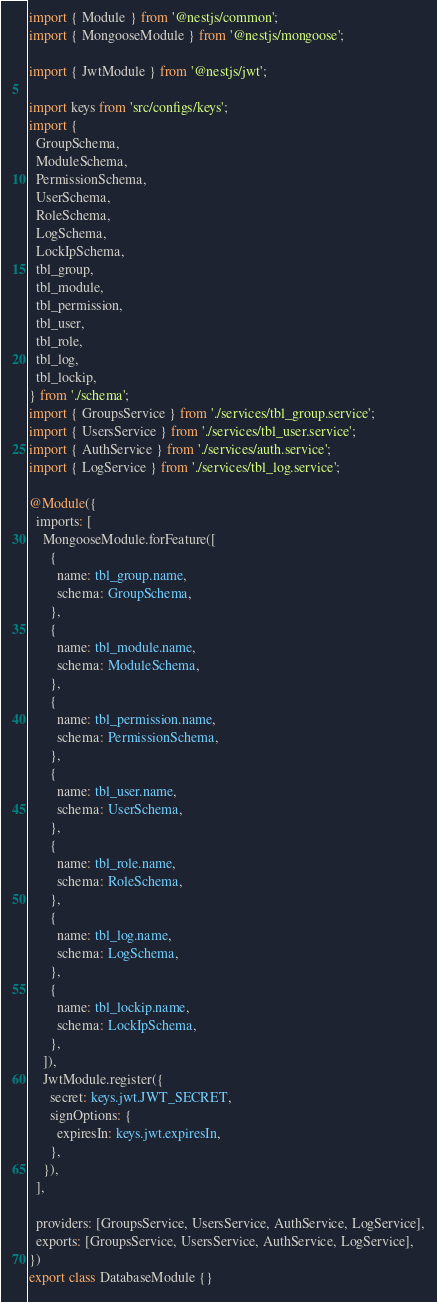<code> <loc_0><loc_0><loc_500><loc_500><_TypeScript_>import { Module } from '@nestjs/common';
import { MongooseModule } from '@nestjs/mongoose';

import { JwtModule } from '@nestjs/jwt';

import keys from 'src/configs/keys';
import {
  GroupSchema,
  ModuleSchema,
  PermissionSchema,
  UserSchema,
  RoleSchema,
  LogSchema,
  LockIpSchema,
  tbl_group,
  tbl_module,
  tbl_permission,
  tbl_user,
  tbl_role,
  tbl_log,
  tbl_lockip,
} from './schema';
import { GroupsService } from './services/tbl_group.service';
import { UsersService } from './services/tbl_user.service';
import { AuthService } from './services/auth.service';
import { LogService } from './services/tbl_log.service';

@Module({
  imports: [
    MongooseModule.forFeature([
      {
        name: tbl_group.name,
        schema: GroupSchema,
      },
      {
        name: tbl_module.name,
        schema: ModuleSchema,
      },
      {
        name: tbl_permission.name,
        schema: PermissionSchema,
      },
      {
        name: tbl_user.name,
        schema: UserSchema,
      },
      {
        name: tbl_role.name,
        schema: RoleSchema,
      },
      {
        name: tbl_log.name,
        schema: LogSchema,
      },
      {
        name: tbl_lockip.name,
        schema: LockIpSchema,
      },
    ]),
    JwtModule.register({
      secret: keys.jwt.JWT_SECRET,
      signOptions: {
        expiresIn: keys.jwt.expiresIn,
      },
    }),
  ],

  providers: [GroupsService, UsersService, AuthService, LogService],
  exports: [GroupsService, UsersService, AuthService, LogService],
})
export class DatabaseModule {}
</code> 